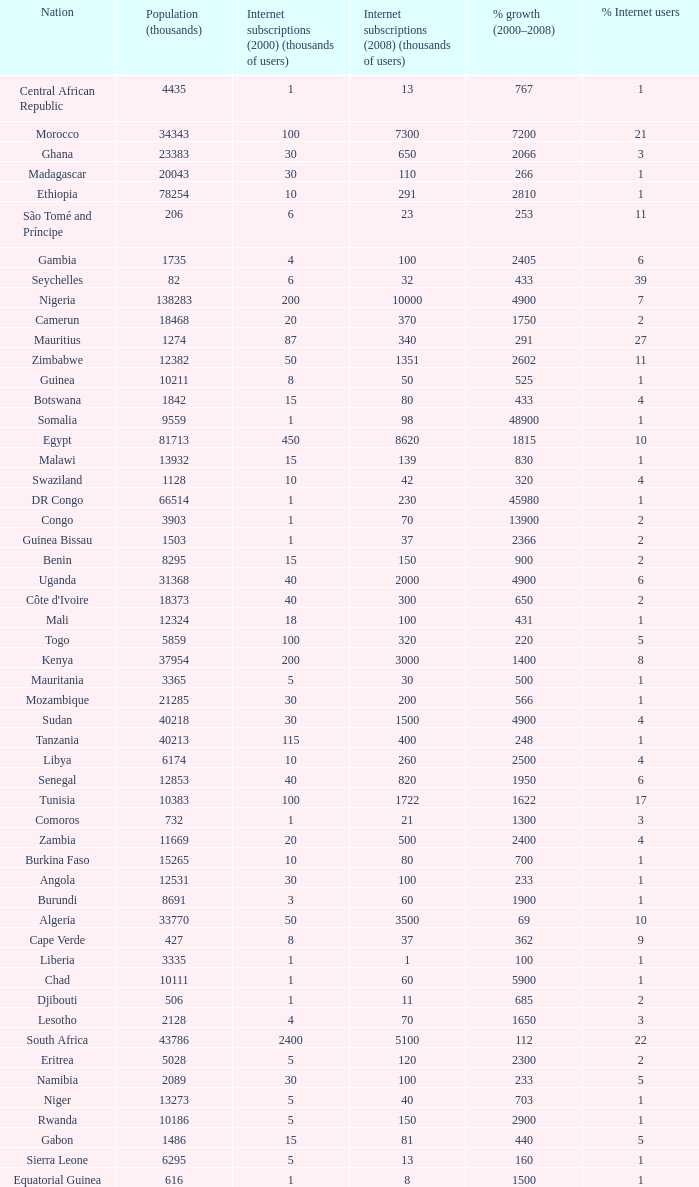Name the total number of percentage growth 2000-2008 of uganda? 1.0. 